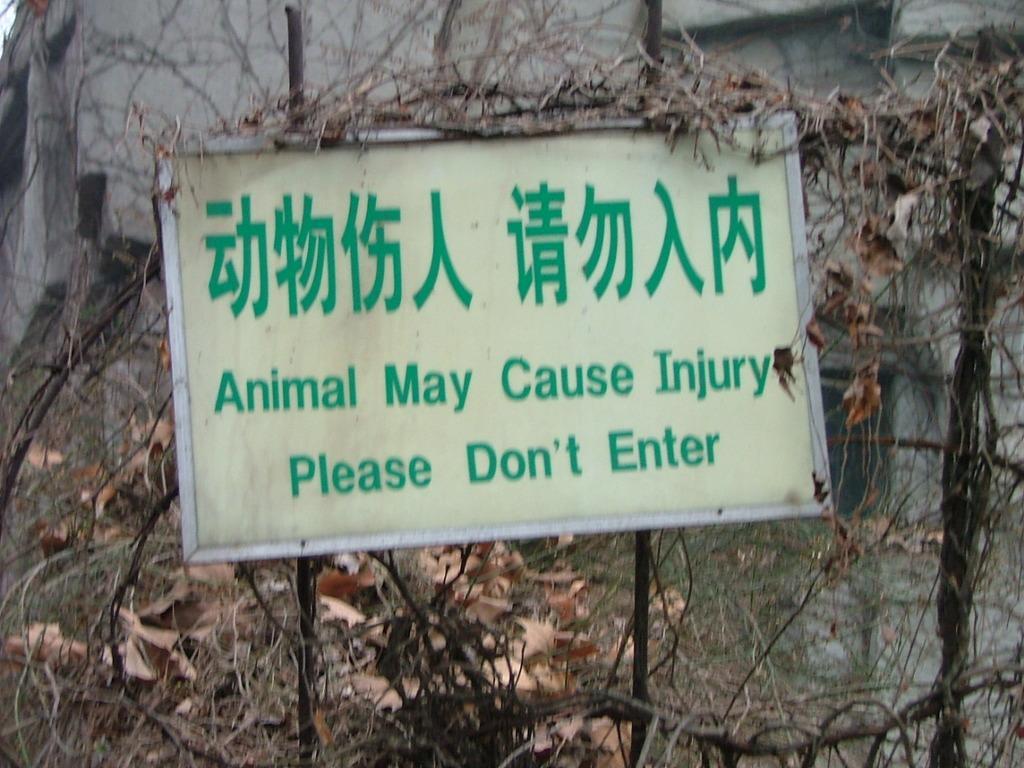Can you describe this image briefly? In this image we can see a board on which something is written in green color. In the background, we can see wire fence, dry leaves and a building. 